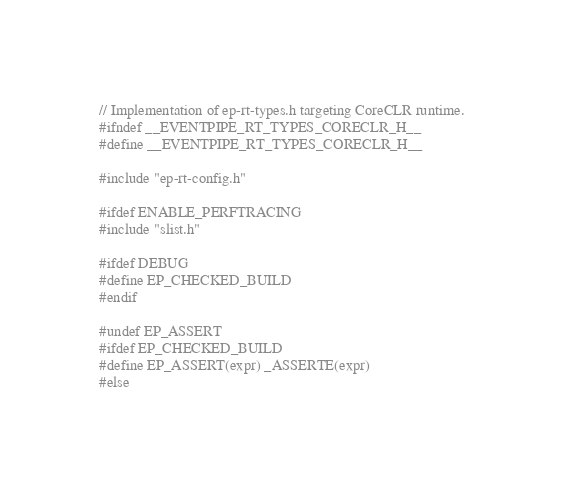Convert code to text. <code><loc_0><loc_0><loc_500><loc_500><_C_>// Implementation of ep-rt-types.h targeting CoreCLR runtime.
#ifndef __EVENTPIPE_RT_TYPES_CORECLR_H__
#define __EVENTPIPE_RT_TYPES_CORECLR_H__

#include "ep-rt-config.h"

#ifdef ENABLE_PERFTRACING
#include "slist.h"

#ifdef DEBUG
#define EP_CHECKED_BUILD
#endif

#undef EP_ASSERT
#ifdef EP_CHECKED_BUILD
#define EP_ASSERT(expr) _ASSERTE(expr)
#else</code> 